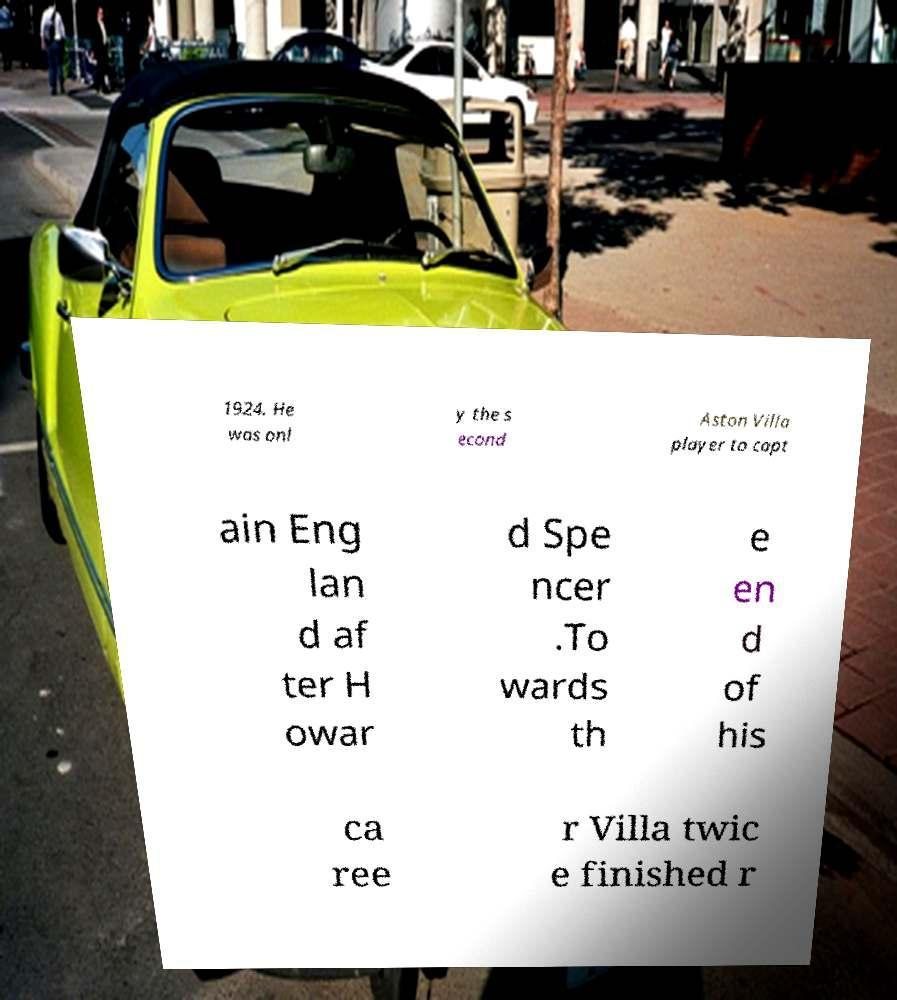Please read and relay the text visible in this image. What does it say? 1924. He was onl y the s econd Aston Villa player to capt ain Eng lan d af ter H owar d Spe ncer .To wards th e en d of his ca ree r Villa twic e finished r 